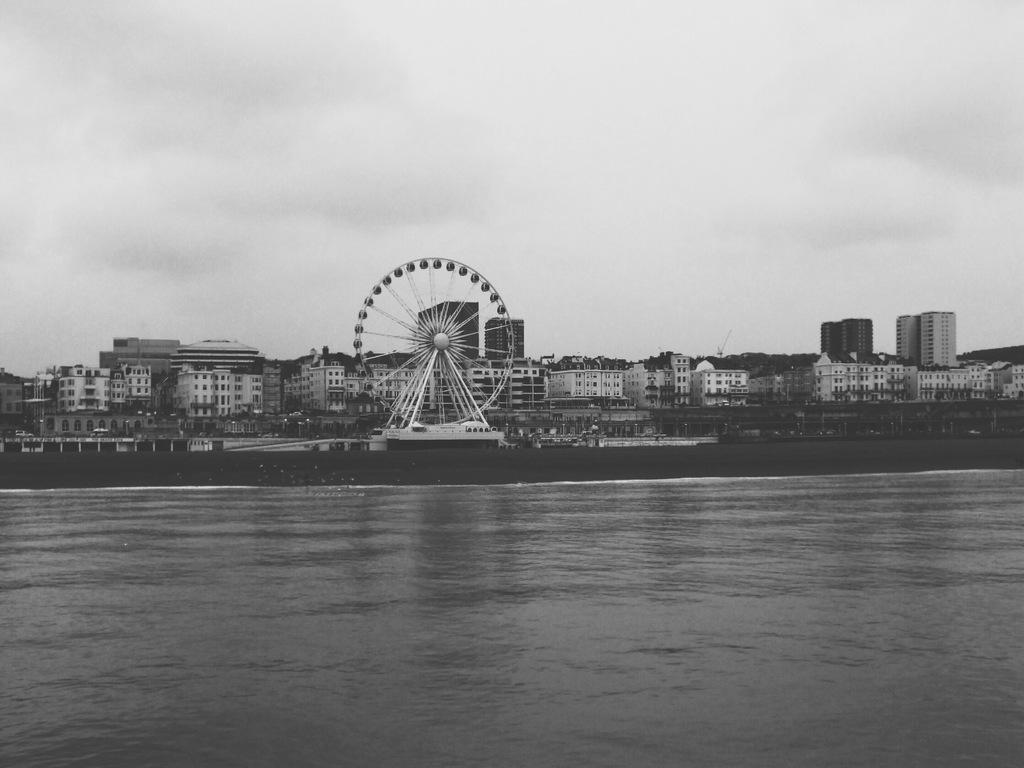Describe this image in one or two sentences. This is a black and white picture. I can see water, there is a Ferris wheel, there are buildings, trees, and in the background there is sky. 